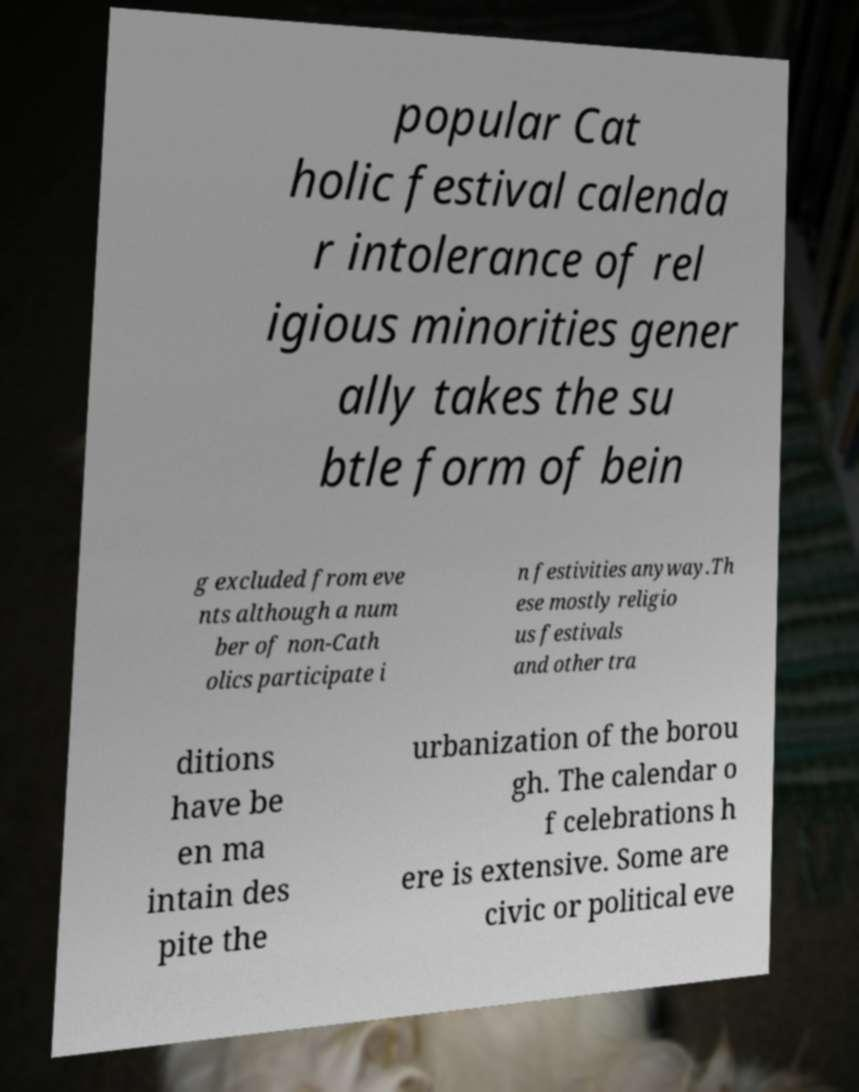Can you read and provide the text displayed in the image?This photo seems to have some interesting text. Can you extract and type it out for me? popular Cat holic festival calenda r intolerance of rel igious minorities gener ally takes the su btle form of bein g excluded from eve nts although a num ber of non-Cath olics participate i n festivities anyway.Th ese mostly religio us festivals and other tra ditions have be en ma intain des pite the urbanization of the borou gh. The calendar o f celebrations h ere is extensive. Some are civic or political eve 